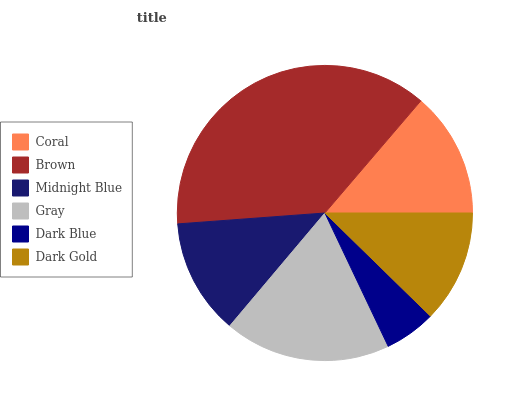Is Dark Blue the minimum?
Answer yes or no. Yes. Is Brown the maximum?
Answer yes or no. Yes. Is Midnight Blue the minimum?
Answer yes or no. No. Is Midnight Blue the maximum?
Answer yes or no. No. Is Brown greater than Midnight Blue?
Answer yes or no. Yes. Is Midnight Blue less than Brown?
Answer yes or no. Yes. Is Midnight Blue greater than Brown?
Answer yes or no. No. Is Brown less than Midnight Blue?
Answer yes or no. No. Is Coral the high median?
Answer yes or no. Yes. Is Midnight Blue the low median?
Answer yes or no. Yes. Is Dark Blue the high median?
Answer yes or no. No. Is Dark Gold the low median?
Answer yes or no. No. 